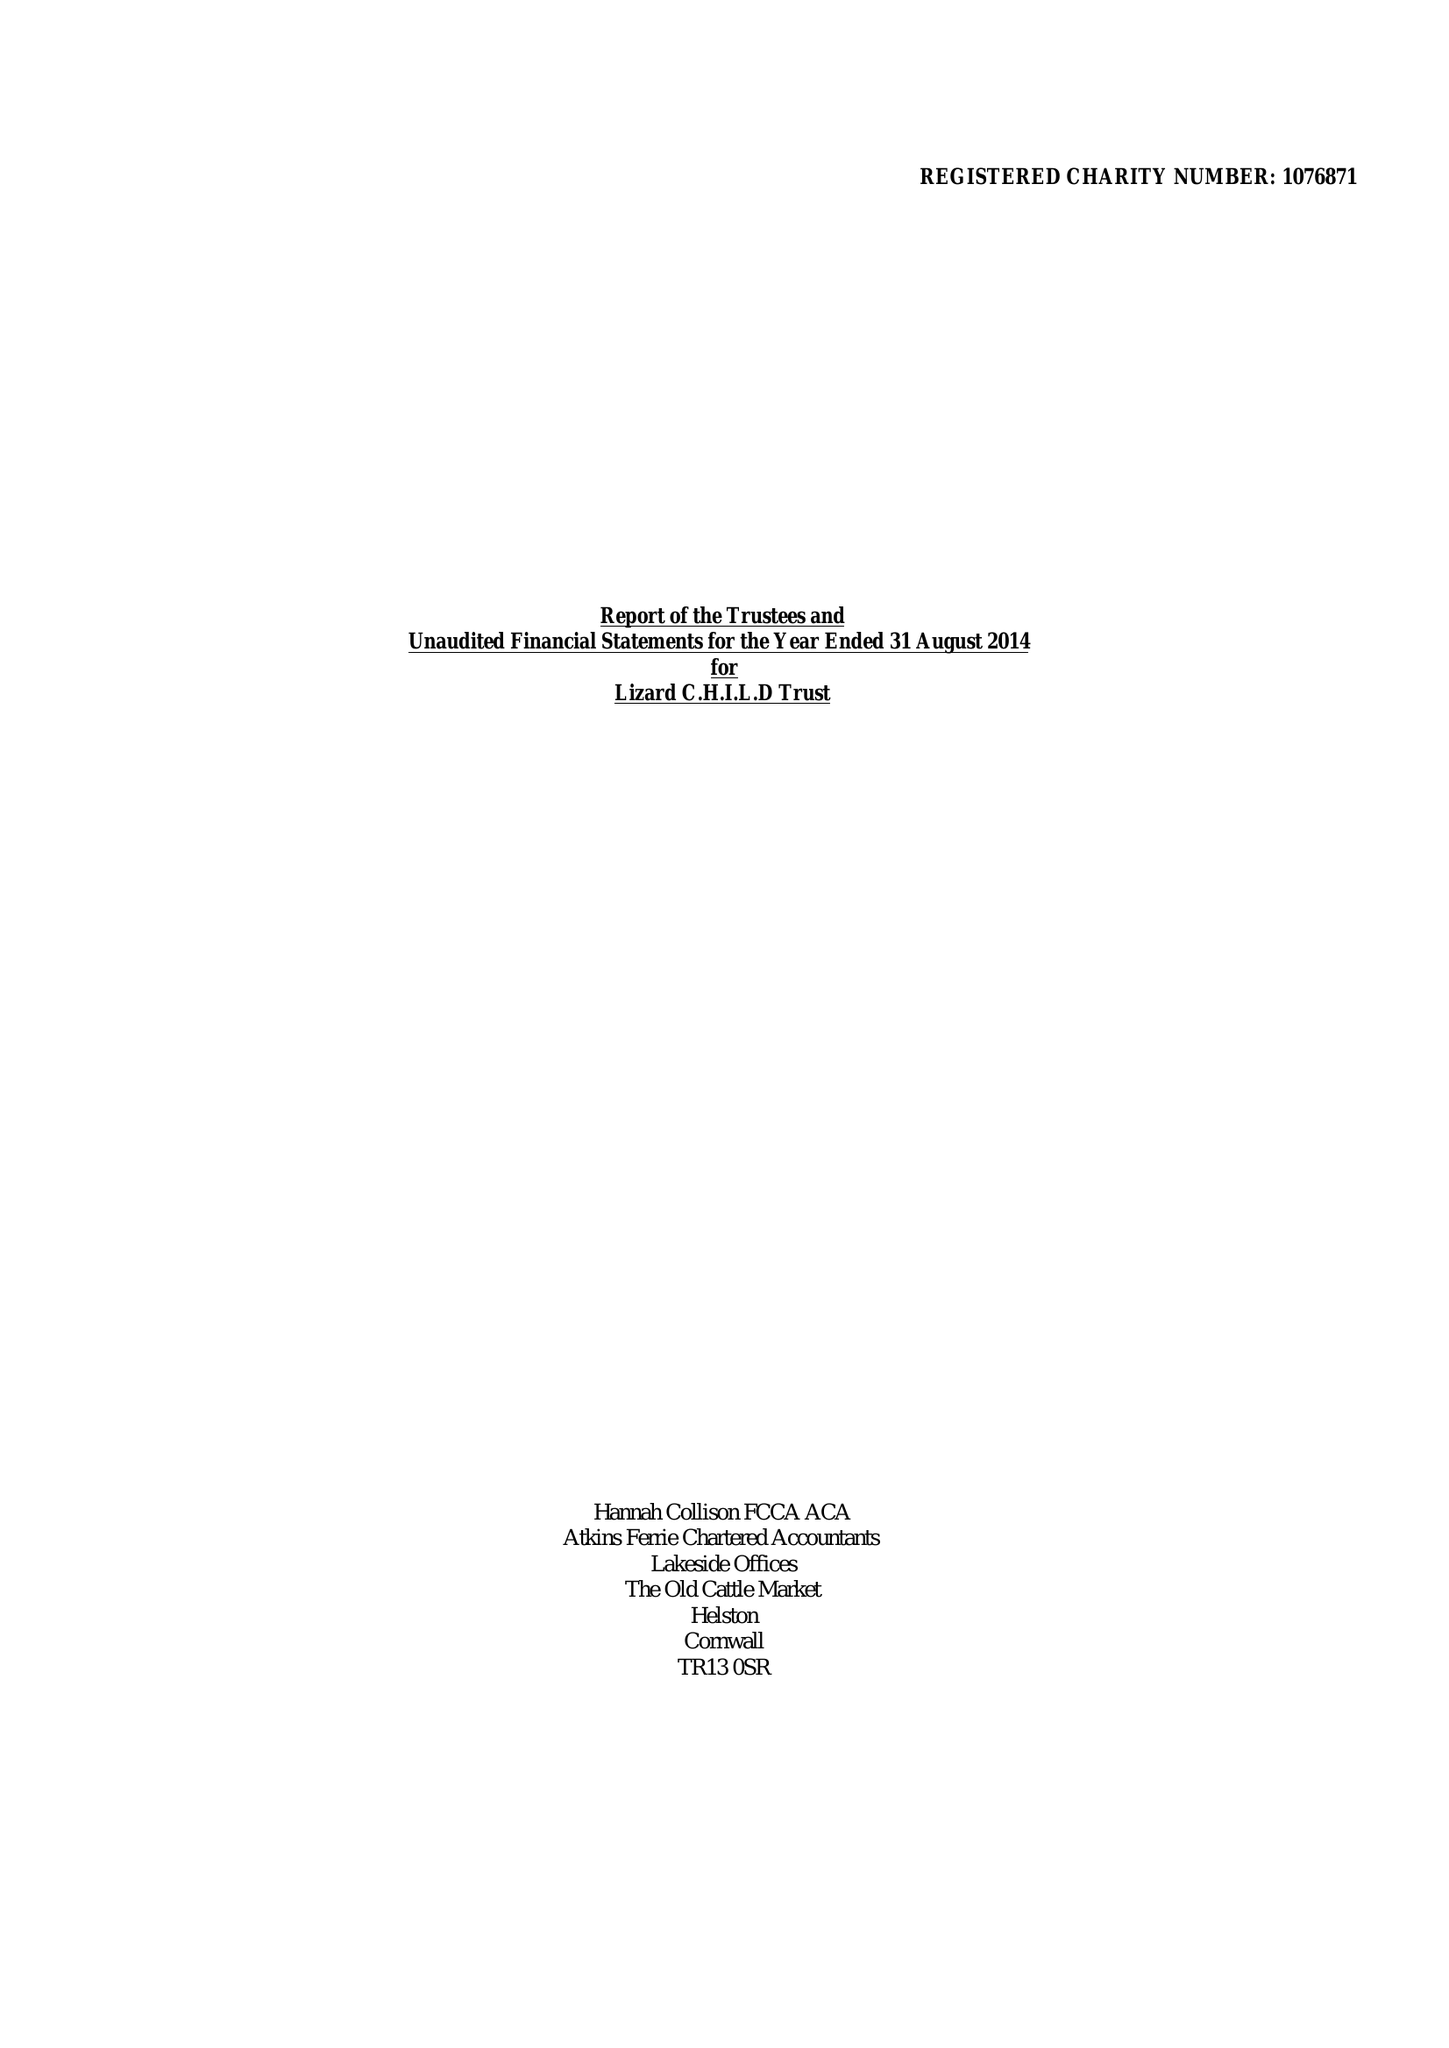What is the value for the address__street_line?
Answer the question using a single word or phrase. PENBERTHY ROAD 